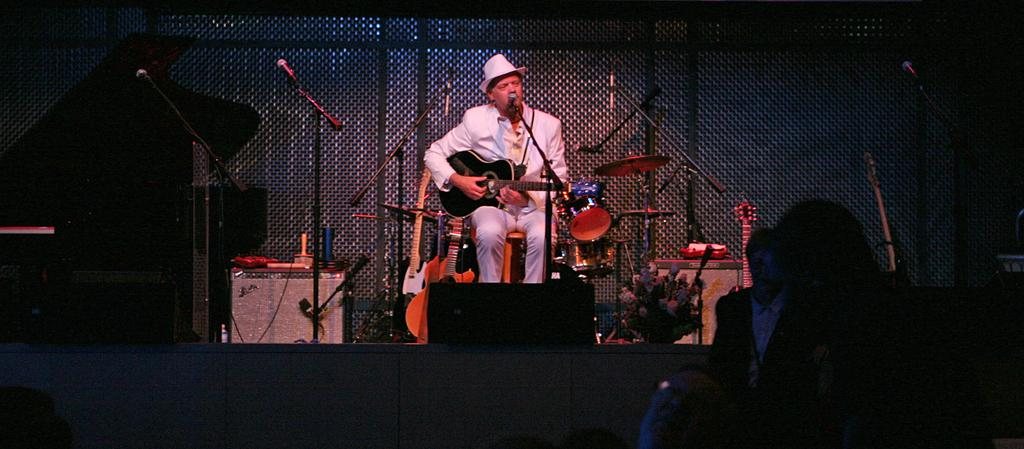What is the person in the image doing? The person is sitting and playing a guitar, and also singing. Can you describe the person's attire? The person is wearing a cap. What equipment is present in the image for amplifying sound? There are microphones with stands in the image. What other musical instruments can be seen in the image? There are musical instruments in the image, but the specific instruments are not mentioned in the facts. What is the purpose of the fence in the image? The purpose of the fence in the image is not mentioned in the facts. Who is the person performing for in the image? There is an audience in the image, so the person is performing for them. What type of eggnog is being served to the audience in the image? There is no mention of eggnog or any food or beverage being served in the image. 